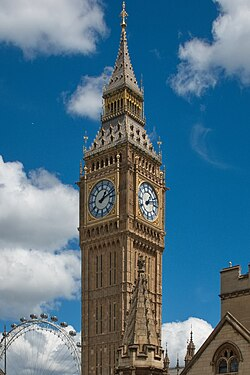Suppose you are visiting this location, what activities might you do nearby? As a visitor near Big Ben and the Palace of Westminster: You might start by absorbing the breathtaking architecture and historical significance of Big Ben, arguably one of London’s most famous landmarks. A guided tour inside the Elizabeth Tower could offer detailed narratives about its construction and its role in British history. Next, you could stroll along the Thames River, perhaps embarking on a boat tour to enjoy the city's skyline from the water. The nearby London Eye provides great panoramic views of London, giving you another perspective of the cityscape. For history buffs, a visit to the British Museum or Churchill War Rooms would be both informative and inspiring. End your day at one of the charming cafes or restaurants in the area, savoring traditional British dishes while enjoying the vibrant atmosphere of Westminster. 